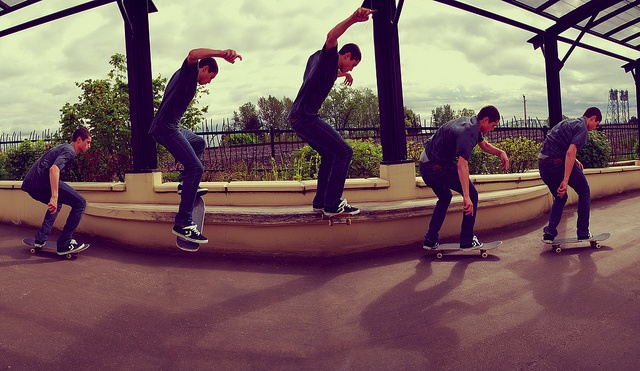Describe the objects in this image and their specific colors. I can see people in purple, navy, and brown tones, people in purple, navy, maroon, and beige tones, people in purple, navy, maroon, and brown tones, people in purple, navy, and brown tones, and people in purple, navy, and brown tones in this image. 